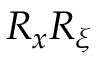<formula> <loc_0><loc_0><loc_500><loc_500>R _ { x } R _ { \xi }</formula> 